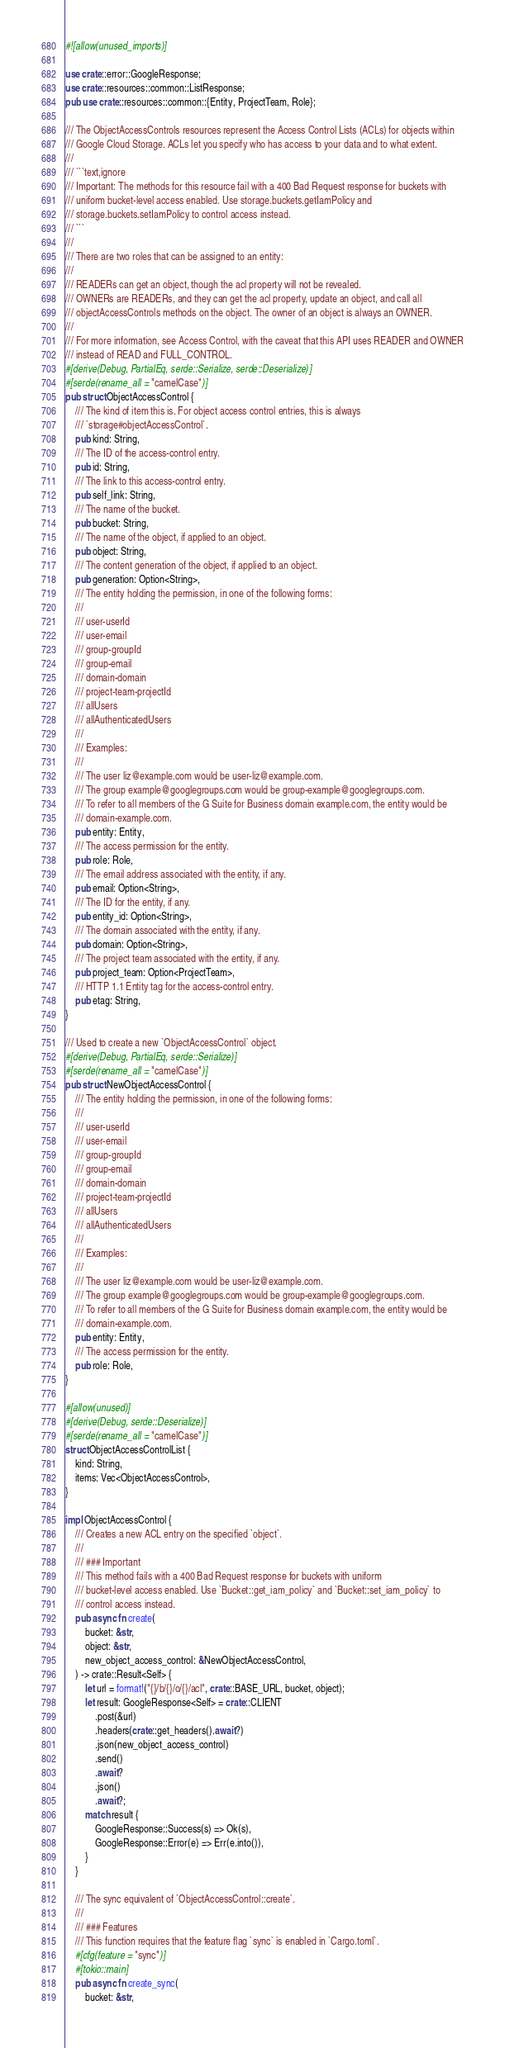<code> <loc_0><loc_0><loc_500><loc_500><_Rust_>#![allow(unused_imports)]

use crate::error::GoogleResponse;
use crate::resources::common::ListResponse;
pub use crate::resources::common::{Entity, ProjectTeam, Role};

/// The ObjectAccessControls resources represent the Access Control Lists (ACLs) for objects within
/// Google Cloud Storage. ACLs let you specify who has access to your data and to what extent.
///
/// ```text,ignore
/// Important: The methods for this resource fail with a 400 Bad Request response for buckets with
/// uniform bucket-level access enabled. Use storage.buckets.getIamPolicy and
/// storage.buckets.setIamPolicy to control access instead.
/// ```
///
/// There are two roles that can be assigned to an entity:
///
/// READERs can get an object, though the acl property will not be revealed.
/// OWNERs are READERs, and they can get the acl property, update an object, and call all
/// objectAccessControls methods on the object. The owner of an object is always an OWNER.
///
/// For more information, see Access Control, with the caveat that this API uses READER and OWNER
/// instead of READ and FULL_CONTROL.
#[derive(Debug, PartialEq, serde::Serialize, serde::Deserialize)]
#[serde(rename_all = "camelCase")]
pub struct ObjectAccessControl {
    /// The kind of item this is. For object access control entries, this is always
    /// `storage#objectAccessControl`.
    pub kind: String,
    /// The ID of the access-control entry.
    pub id: String,
    /// The link to this access-control entry.
    pub self_link: String,
    /// The name of the bucket.
    pub bucket: String,
    /// The name of the object, if applied to an object.
    pub object: String,
    /// The content generation of the object, if applied to an object.
    pub generation: Option<String>,
    /// The entity holding the permission, in one of the following forms:
    ///
    /// user-userId
    /// user-email
    /// group-groupId
    /// group-email
    /// domain-domain
    /// project-team-projectId
    /// allUsers
    /// allAuthenticatedUsers
    ///
    /// Examples:
    ///
    /// The user liz@example.com would be user-liz@example.com.
    /// The group example@googlegroups.com would be group-example@googlegroups.com.
    /// To refer to all members of the G Suite for Business domain example.com, the entity would be
    /// domain-example.com.
    pub entity: Entity,
    /// The access permission for the entity.
    pub role: Role,
    /// The email address associated with the entity, if any.
    pub email: Option<String>,
    /// The ID for the entity, if any.
    pub entity_id: Option<String>,
    /// The domain associated with the entity, if any.
    pub domain: Option<String>,
    /// The project team associated with the entity, if any.
    pub project_team: Option<ProjectTeam>,
    /// HTTP 1.1 Entity tag for the access-control entry.
    pub etag: String,
}

/// Used to create a new `ObjectAccessControl` object.
#[derive(Debug, PartialEq, serde::Serialize)]
#[serde(rename_all = "camelCase")]
pub struct NewObjectAccessControl {
    /// The entity holding the permission, in one of the following forms:
    ///
    /// user-userId
    /// user-email
    /// group-groupId
    /// group-email
    /// domain-domain
    /// project-team-projectId
    /// allUsers
    /// allAuthenticatedUsers
    ///
    /// Examples:
    ///
    /// The user liz@example.com would be user-liz@example.com.
    /// The group example@googlegroups.com would be group-example@googlegroups.com.
    /// To refer to all members of the G Suite for Business domain example.com, the entity would be
    /// domain-example.com.
    pub entity: Entity,
    /// The access permission for the entity.
    pub role: Role,
}

#[allow(unused)]
#[derive(Debug, serde::Deserialize)]
#[serde(rename_all = "camelCase")]
struct ObjectAccessControlList {
    kind: String,
    items: Vec<ObjectAccessControl>,
}

impl ObjectAccessControl {
    /// Creates a new ACL entry on the specified `object`.
    ///
    /// ### Important
    /// This method fails with a 400 Bad Request response for buckets with uniform
    /// bucket-level access enabled. Use `Bucket::get_iam_policy` and `Bucket::set_iam_policy` to
    /// control access instead.
    pub async fn create(
        bucket: &str,
        object: &str,
        new_object_access_control: &NewObjectAccessControl,
    ) -> crate::Result<Self> {
        let url = format!("{}/b/{}/o/{}/acl", crate::BASE_URL, bucket, object);
        let result: GoogleResponse<Self> = crate::CLIENT
            .post(&url)
            .headers(crate::get_headers().await?)
            .json(new_object_access_control)
            .send()
            .await?
            .json()
            .await?;
        match result {
            GoogleResponse::Success(s) => Ok(s),
            GoogleResponse::Error(e) => Err(e.into()),
        }
    }

    /// The sync equivalent of `ObjectAccessControl::create`.
    ///
    /// ### Features
    /// This function requires that the feature flag `sync` is enabled in `Cargo.toml`.
    #[cfg(feature = "sync")]
    #[tokio::main]
    pub async fn create_sync(
        bucket: &str,</code> 